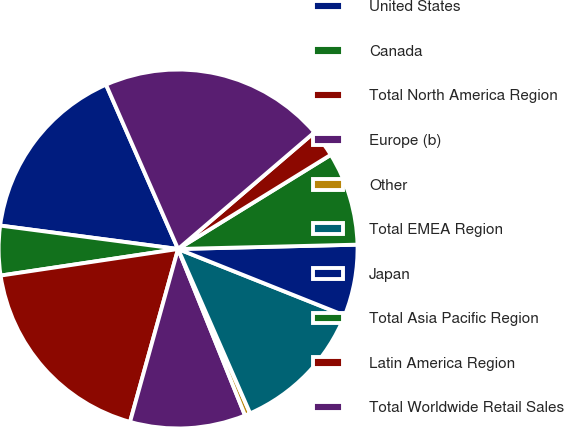Convert chart. <chart><loc_0><loc_0><loc_500><loc_500><pie_chart><fcel>United States<fcel>Canada<fcel>Total North America Region<fcel>Europe (b)<fcel>Other<fcel>Total EMEA Region<fcel>Japan<fcel>Total Asia Pacific Region<fcel>Latin America Region<fcel>Total Worldwide Retail Sales<nl><fcel>16.34%<fcel>4.45%<fcel>18.32%<fcel>10.4%<fcel>0.49%<fcel>12.38%<fcel>6.43%<fcel>8.41%<fcel>2.47%<fcel>20.31%<nl></chart> 